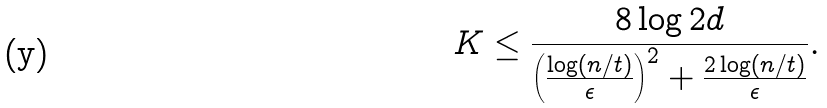Convert formula to latex. <formula><loc_0><loc_0><loc_500><loc_500>K \leq \frac { 8 \log 2 d } { \left ( \frac { \log ( n / t ) } { \epsilon } \right ) ^ { 2 } + \frac { 2 \log ( n / t ) } { \epsilon } } .</formula> 